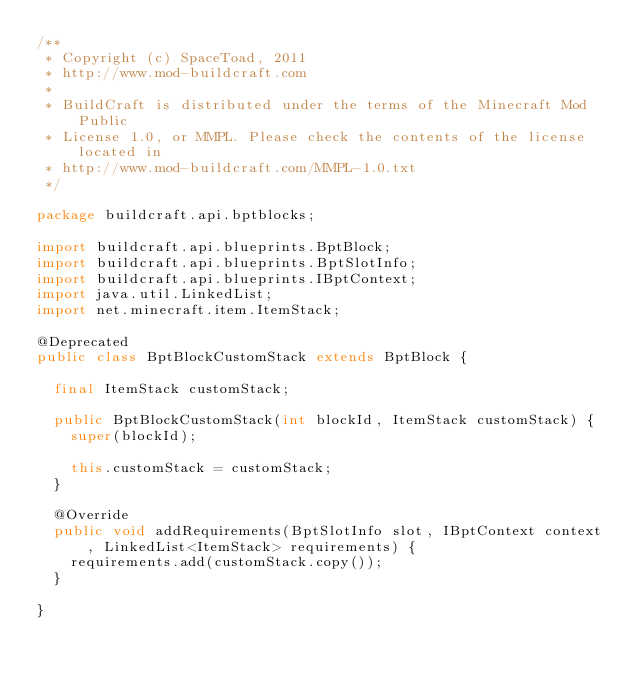Convert code to text. <code><loc_0><loc_0><loc_500><loc_500><_Java_>/** 
 * Copyright (c) SpaceToad, 2011
 * http://www.mod-buildcraft.com
 * 
 * BuildCraft is distributed under the terms of the Minecraft Mod Public 
 * License 1.0, or MMPL. Please check the contents of the license located in
 * http://www.mod-buildcraft.com/MMPL-1.0.txt
 */

package buildcraft.api.bptblocks;

import buildcraft.api.blueprints.BptBlock;
import buildcraft.api.blueprints.BptSlotInfo;
import buildcraft.api.blueprints.IBptContext;
import java.util.LinkedList;
import net.minecraft.item.ItemStack;

@Deprecated
public class BptBlockCustomStack extends BptBlock {

	final ItemStack customStack;

	public BptBlockCustomStack(int blockId, ItemStack customStack) {
		super(blockId);

		this.customStack = customStack;
	}

	@Override
	public void addRequirements(BptSlotInfo slot, IBptContext context, LinkedList<ItemStack> requirements) {
		requirements.add(customStack.copy());
	}

}
</code> 